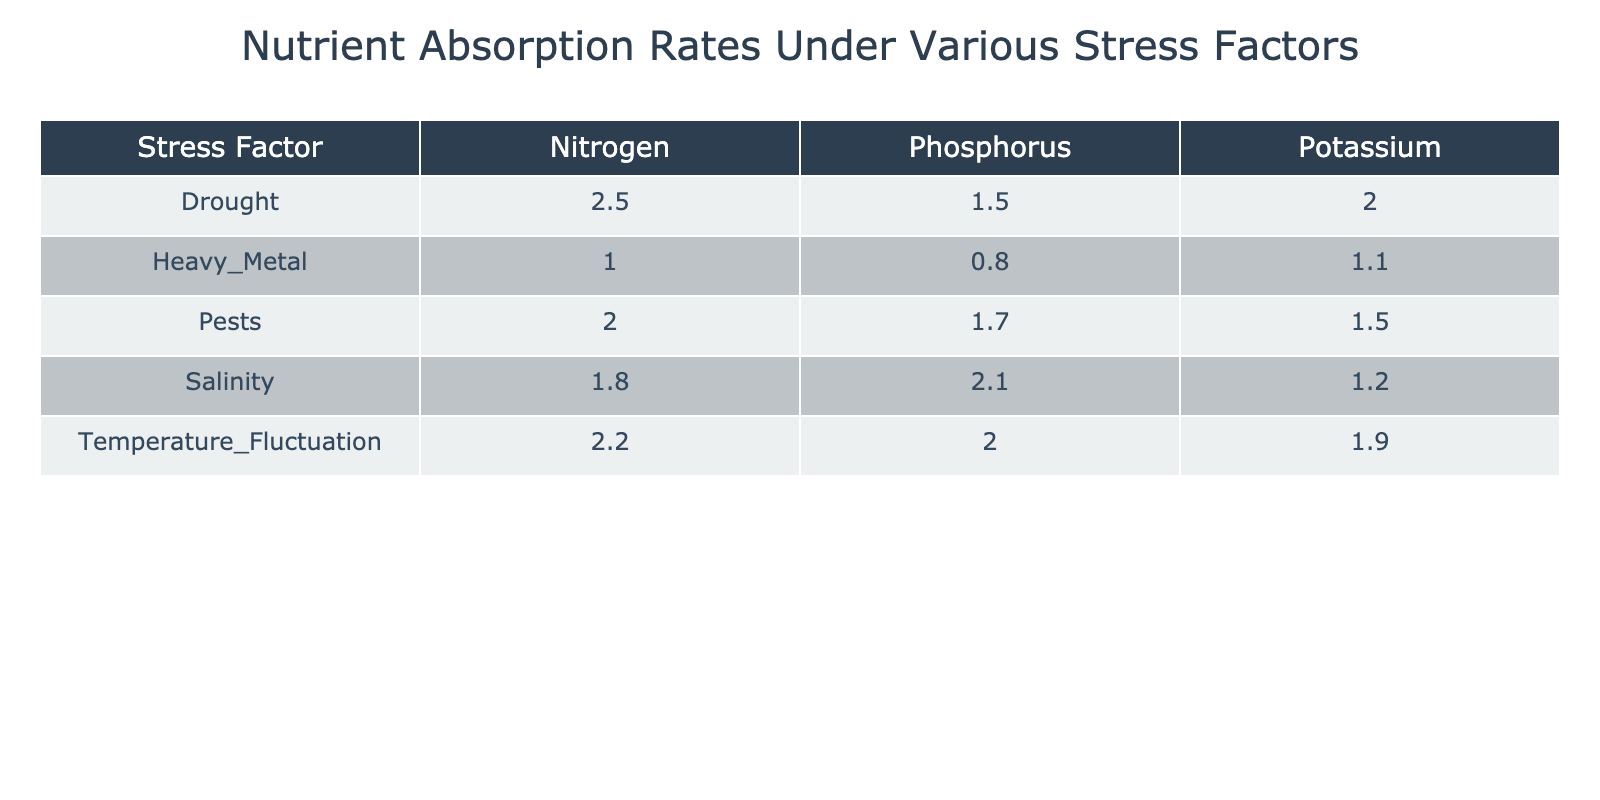What is the nutrient absorption rate of Nitrogen under the Drought stress factor? Referring to the table, the row corresponding to "Drought" and the column for "Nitrogen" shows a value of 2.5 mg/g/d for nutrient absorption rate.
Answer: 2.5 Which stress factor has the lowest Nitrogen absorption rate? The table shows the absorption rates for Nitrogen across different stress factors. The lowest value is found under "Heavy Metal," which is 1.0 mg/g/d.
Answer: Heavy Metal What is the average absorption rate of Potassium across all stress factors? To find the average, we sum the absorption rates for Potassium: (2.0 + 1.2 + 1.1 + 1.9 + 1.5) = 7.7. Since there are 5 data points, we divide: 7.7/5 = 1.54.
Answer: 1.54 Is the perceived cognitive response to Salinity for Phosphorus higher than that of Heavy Metal for Phosphorus? The perceived cognitive response for Salinity with Phosphorus is "Low," while for Heavy Metal with Phosphorus, it is "Very Low." Low is indeed higher than Very Low.
Answer: Yes Which nutrient type has the highest absorption rate under Temperature Fluctuation? Looking at the Temperature Fluctuation row, the highest absorption rate occurs in Nitrogen at 2.2 mg/g/d, compared to Phosphorus (2.0) and Potassium (1.9).
Answer: Nitrogen If we combine the Nitrogen absorption rates for all stress factors, what is the total? The Nitrogen rates are 2.5 (Drought) + 1.8 (Salinity) + 1.0 (Heavy Metal) + 2.2 (Temperature Fluctuation) + 2.0 (Pests), which sums to 10.5 mg/g/d.
Answer: 10.5 Does any stress factor show a moderate perceived cognitive response for all nutrient types? By examining the table, both the Drought and Heavy Metal stress factors do not yield a moderate perceived cognitive response for all nutrient types; they each have low or very low responses for at least one.
Answer: No How does the absorption rate of Phosphorus under Drought compare to Potassium under the same stress factor? Under Drought, Phosphorus has an absorption rate of 1.5 mg/g/d whereas Potassium has a rate of 2.0 mg/g/d; since 2.0 is higher than 1.5, Potassium has a greater rate.
Answer: Potassium has a greater rate 